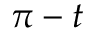<formula> <loc_0><loc_0><loc_500><loc_500>\pi - t</formula> 